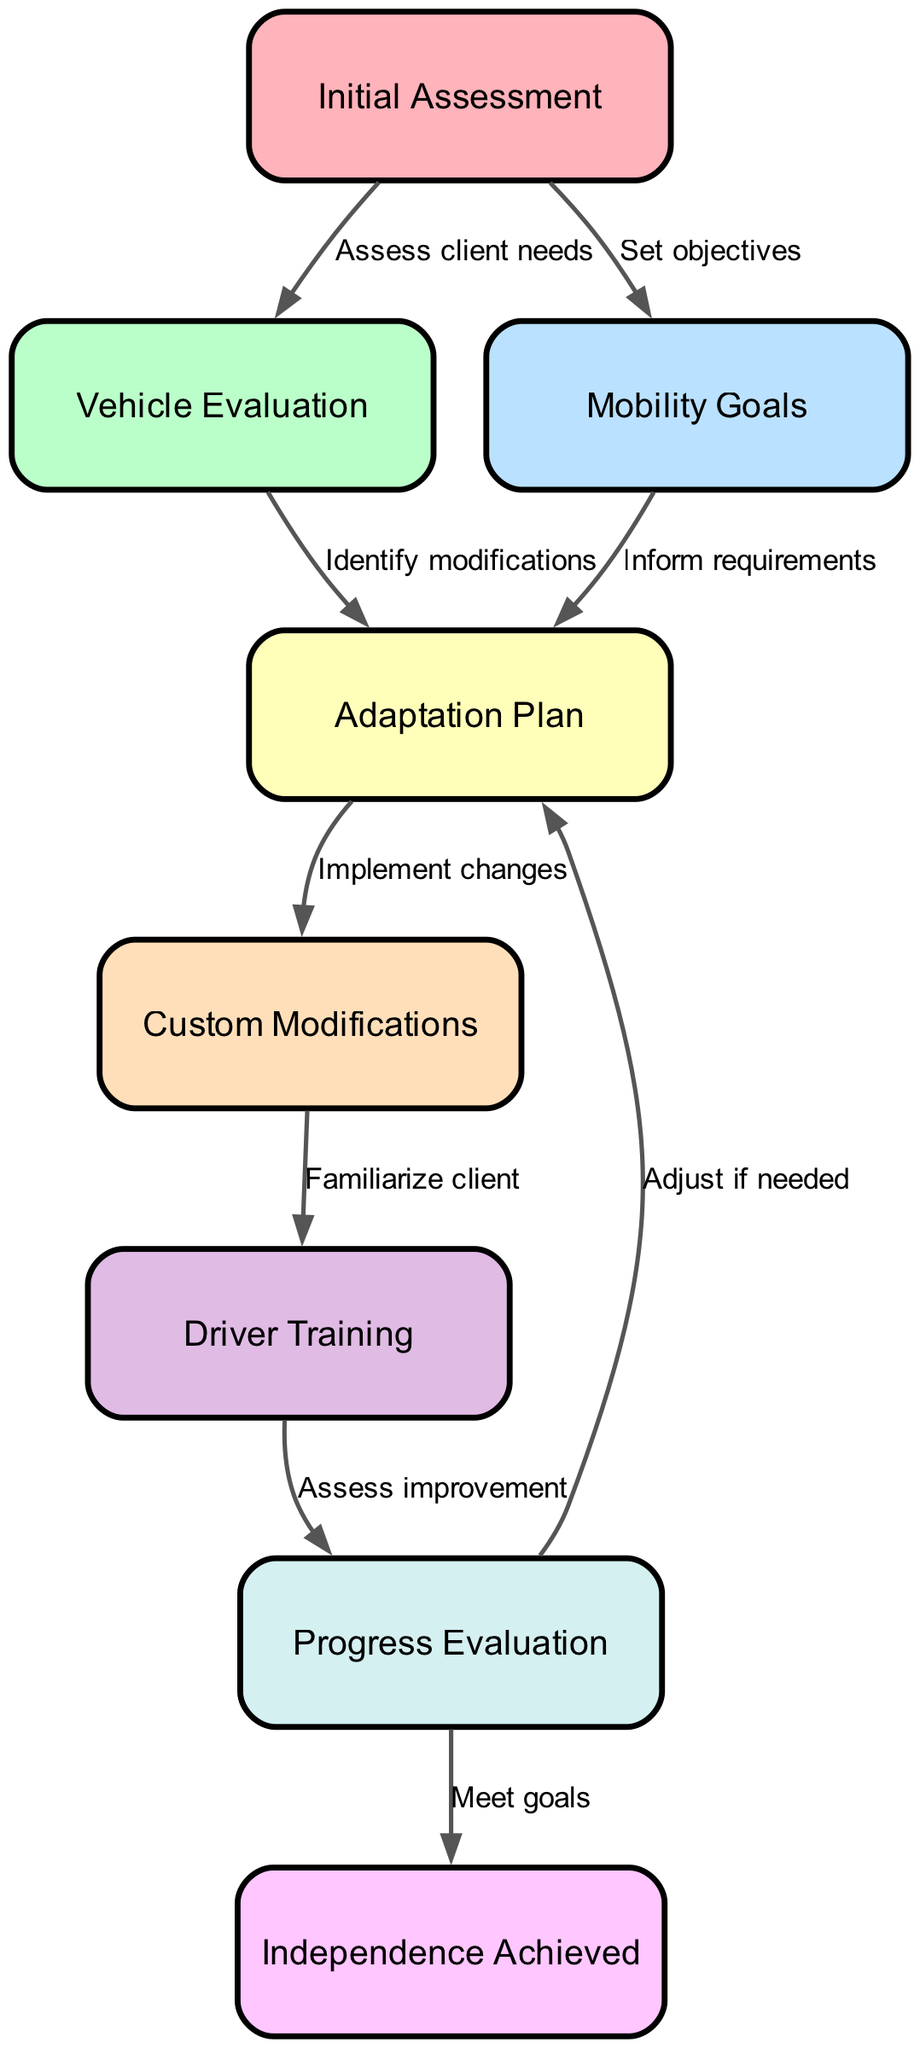What is the starting node in the pathway? The starting node is "Initial Assessment" which is the first node in the diagram, leading to other steps.
Answer: Initial Assessment How many nodes are present in the diagram? There are eight nodes in total including "Independence Achieved," which is the final goal.
Answer: 8 What node comes after "Custom Modifications"? Following "Custom Modifications," the next node in the pathway is "Driver Training," indicating the process after modifications are made.
Answer: Driver Training Which node connects "Mobility Goals" to the next step? "Mobility Goals" connects to "Adaptation Plan," which incorporates the client’s mobility objectives into the modification process.
Answer: Adaptation Plan What is the relationship between "Progress Evaluation" and "Independence Achieved"? "Progress Evaluation" leads to "Independence Achieved," indicating that the assessment of progress is the step that determines whether clients have met their goals.
Answer: Meet goals What step must occur if the "Progress Evaluation" reveals adjustments are necessary? If "Progress Evaluation" suggests adjustments, the pathway leads back to "Adaptation Plan," which indicates modifications may be needed based on evaluation.
Answer: Adjust if needed What labels connect "Vehicle Evaluation" to "Adaptation Plan"? The label connecting "Vehicle Evaluation" to "Adaptation Plan" is "Identify modifications," showing the transition based on needs assessed earlier.
Answer: Identify modifications Which step requires the client to familiarize with modifications? The step where the client familiarizes with modifications is "Driver Training," following the implementation of custom modifications.
Answer: Driver Training 